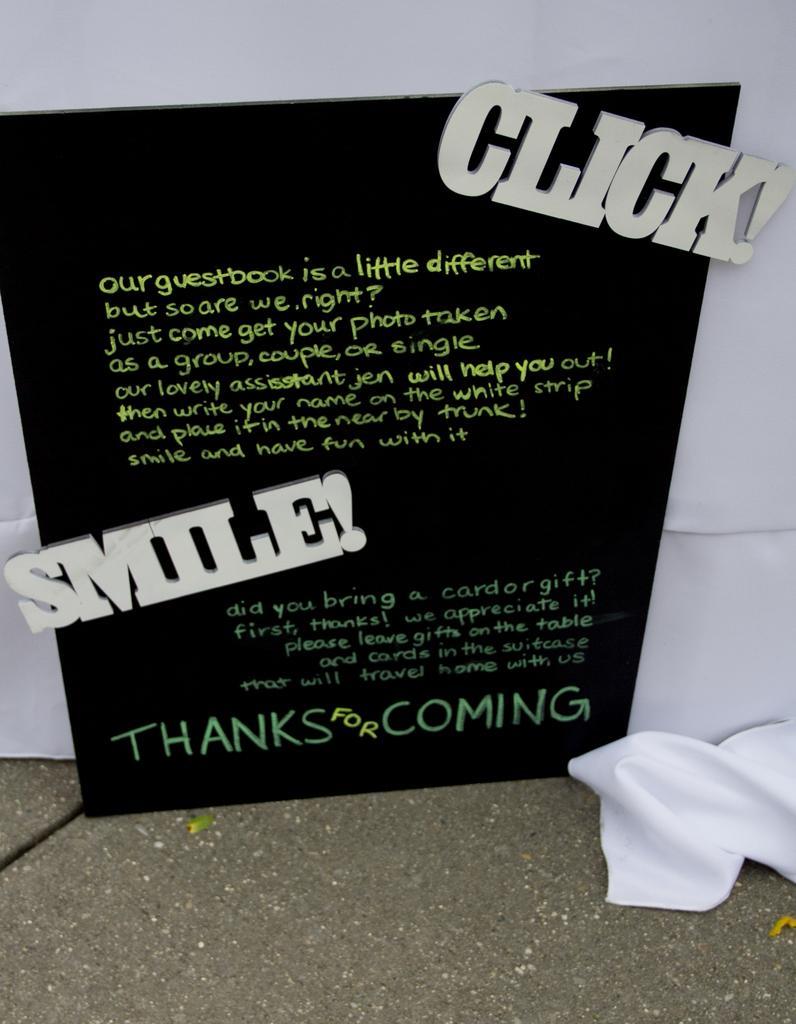Could you give a brief overview of what you see in this image? In the center of the image there is a black color board with some text on it. In the background of the image there is white color cloth. At the bottom of the image there is floor. 